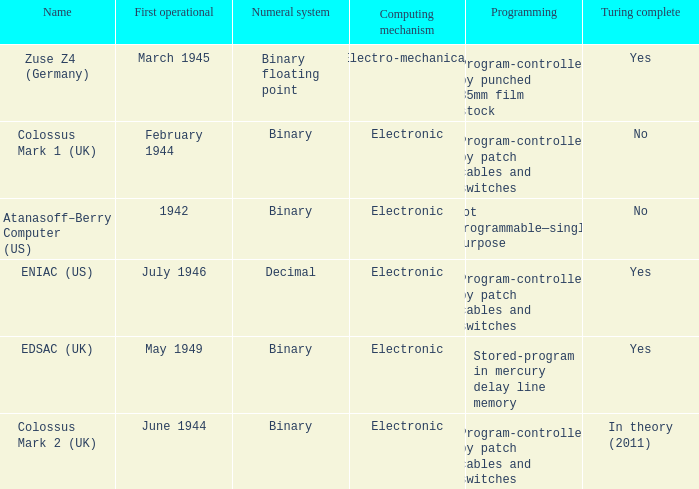What's the turing completeness with the numeric system being decimal? Yes. 